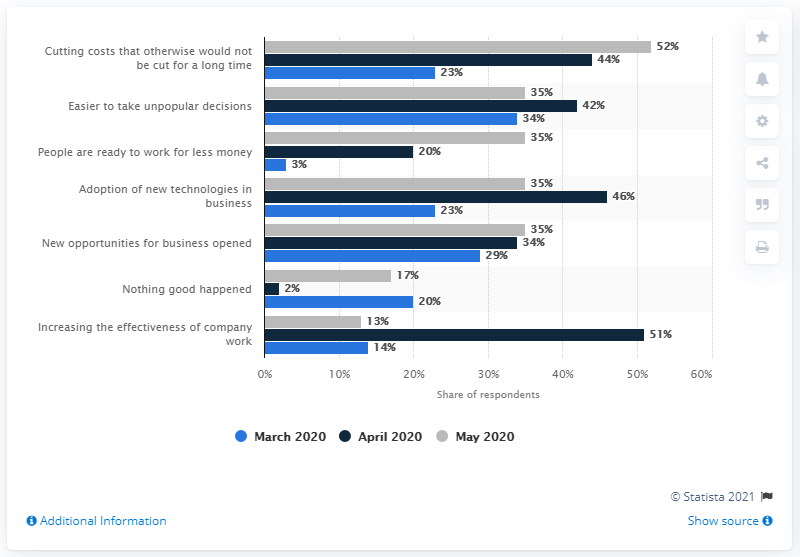Identify some key points in this picture. The COVID-19 pandemic started in May 2020. 